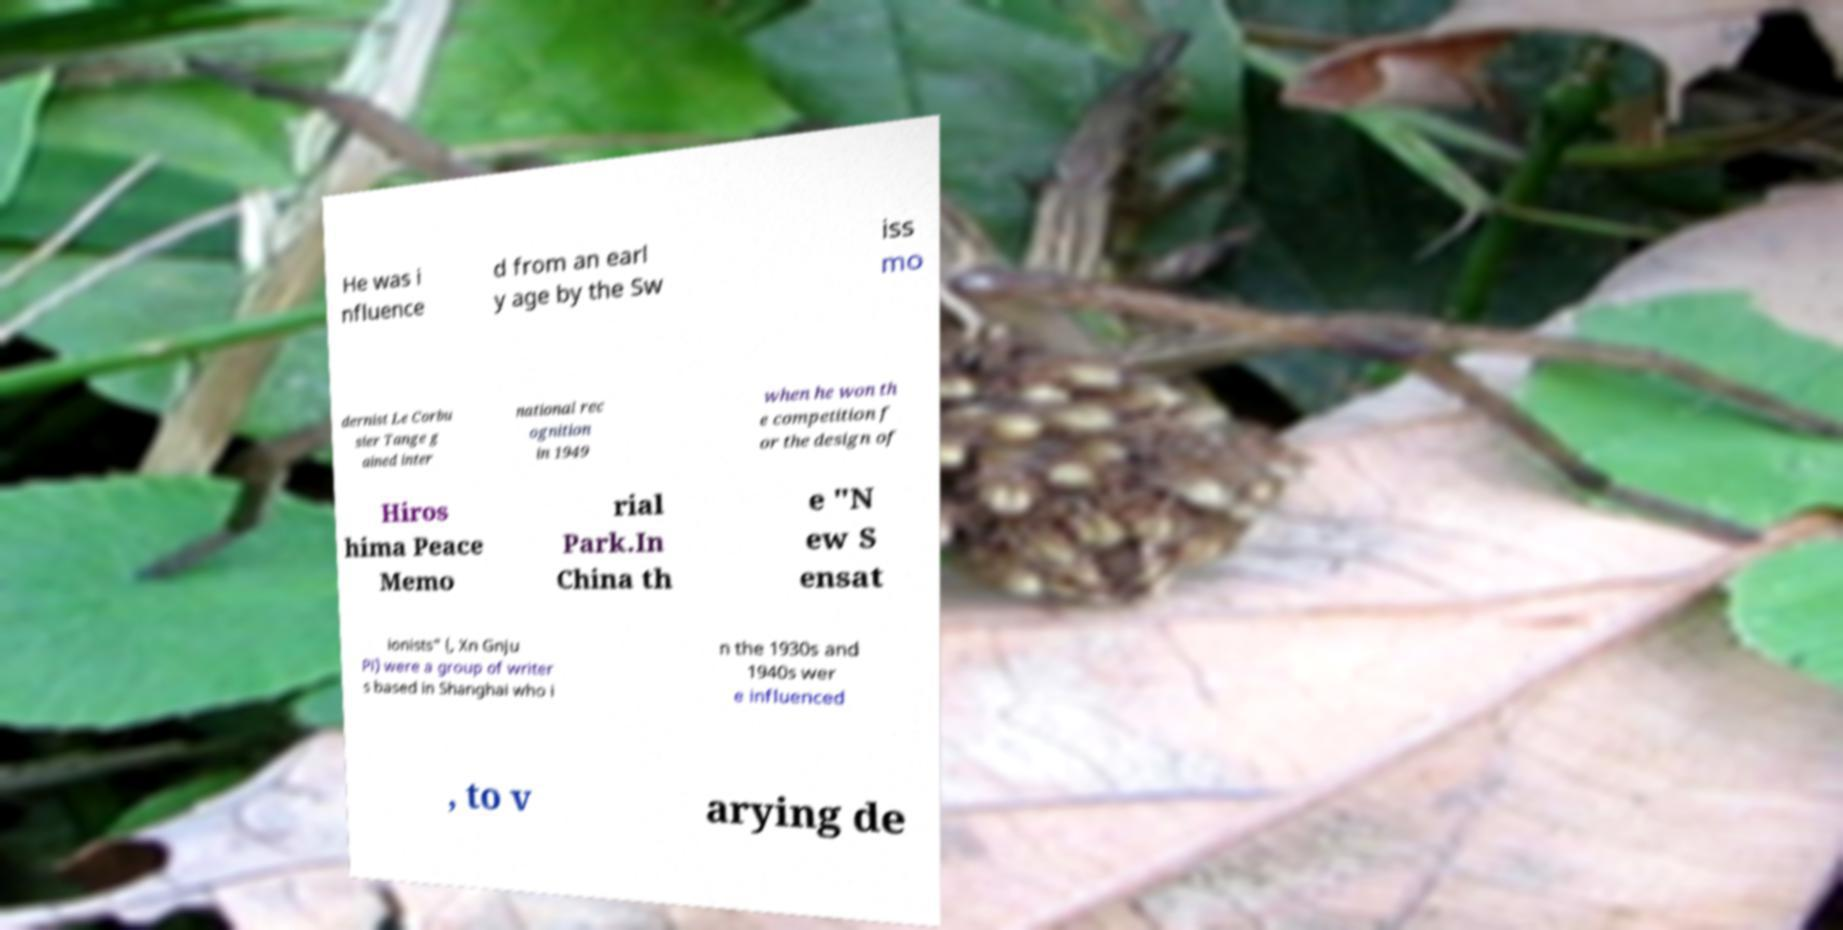I need the written content from this picture converted into text. Can you do that? He was i nfluence d from an earl y age by the Sw iss mo dernist Le Corbu sier Tange g ained inter national rec ognition in 1949 when he won th e competition f or the design of Hiros hima Peace Memo rial Park.In China th e "N ew S ensat ionists" (, Xn Gnju Pi) were a group of writer s based in Shanghai who i n the 1930s and 1940s wer e influenced , to v arying de 